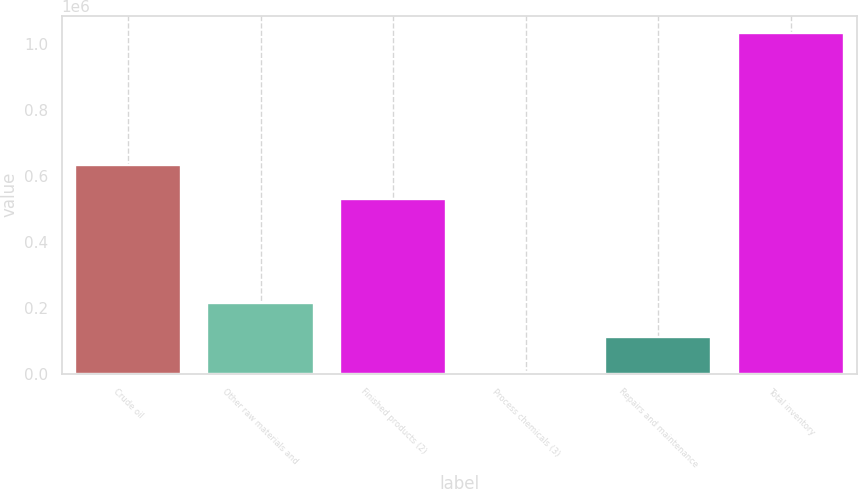Convert chart. <chart><loc_0><loc_0><loc_500><loc_500><bar_chart><fcel>Crude oil<fcel>Other raw materials and<fcel>Finished products (2)<fcel>Process chemicals (3)<fcel>Repairs and maintenance<fcel>Total inventory<nl><fcel>634633<fcel>214109<fcel>531523<fcel>4028<fcel>110999<fcel>1.03513e+06<nl></chart> 